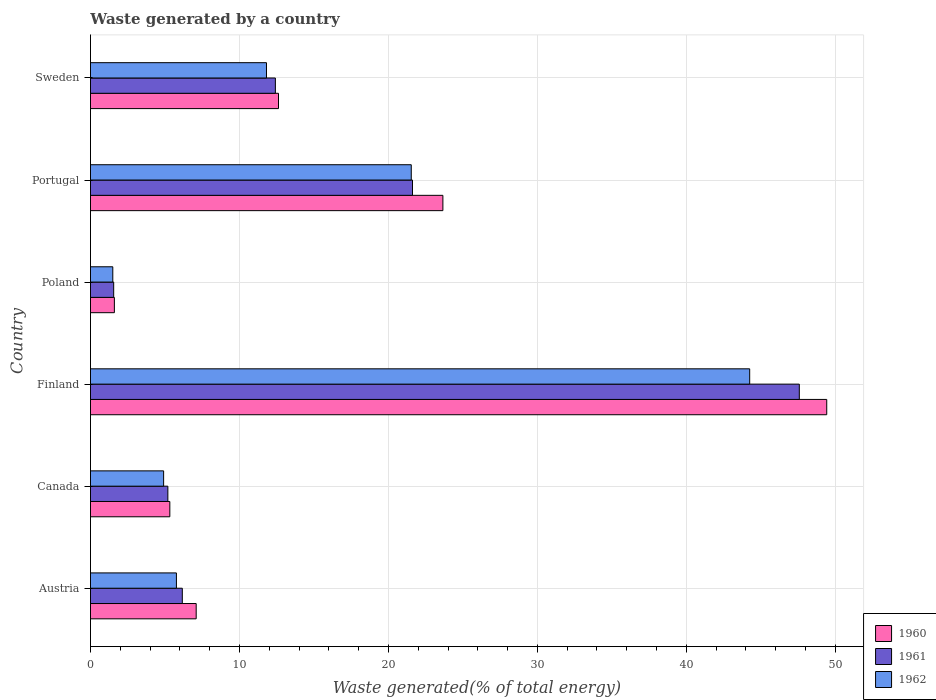How many different coloured bars are there?
Provide a short and direct response. 3. Are the number of bars on each tick of the Y-axis equal?
Ensure brevity in your answer.  Yes. What is the label of the 1st group of bars from the top?
Your answer should be very brief. Sweden. In how many cases, is the number of bars for a given country not equal to the number of legend labels?
Your answer should be very brief. 0. What is the total waste generated in 1960 in Poland?
Your response must be concise. 1.6. Across all countries, what is the maximum total waste generated in 1960?
Provide a succinct answer. 49.42. Across all countries, what is the minimum total waste generated in 1962?
Your answer should be compact. 1.5. In which country was the total waste generated in 1960 minimum?
Keep it short and to the point. Poland. What is the total total waste generated in 1961 in the graph?
Your response must be concise. 94.53. What is the difference between the total waste generated in 1962 in Austria and that in Portugal?
Your response must be concise. -15.76. What is the difference between the total waste generated in 1960 in Portugal and the total waste generated in 1961 in Sweden?
Your answer should be compact. 11.24. What is the average total waste generated in 1962 per country?
Ensure brevity in your answer.  14.96. What is the difference between the total waste generated in 1962 and total waste generated in 1961 in Finland?
Provide a short and direct response. -3.33. In how many countries, is the total waste generated in 1960 greater than 24 %?
Ensure brevity in your answer.  1. What is the ratio of the total waste generated in 1962 in Austria to that in Canada?
Provide a short and direct response. 1.17. Is the total waste generated in 1962 in Poland less than that in Sweden?
Your answer should be compact. Yes. Is the difference between the total waste generated in 1962 in Canada and Sweden greater than the difference between the total waste generated in 1961 in Canada and Sweden?
Your response must be concise. Yes. What is the difference between the highest and the second highest total waste generated in 1961?
Keep it short and to the point. 25.96. What is the difference between the highest and the lowest total waste generated in 1962?
Provide a succinct answer. 42.75. Is the sum of the total waste generated in 1962 in Portugal and Sweden greater than the maximum total waste generated in 1961 across all countries?
Offer a very short reply. No. What does the 3rd bar from the bottom in Poland represents?
Your response must be concise. 1962. How many bars are there?
Your answer should be compact. 18. Are all the bars in the graph horizontal?
Offer a terse response. Yes. Does the graph contain any zero values?
Provide a short and direct response. No. Where does the legend appear in the graph?
Make the answer very short. Bottom right. How are the legend labels stacked?
Your answer should be compact. Vertical. What is the title of the graph?
Your answer should be compact. Waste generated by a country. Does "2007" appear as one of the legend labels in the graph?
Keep it short and to the point. No. What is the label or title of the X-axis?
Offer a terse response. Waste generated(% of total energy). What is the label or title of the Y-axis?
Keep it short and to the point. Country. What is the Waste generated(% of total energy) in 1960 in Austria?
Provide a short and direct response. 7.1. What is the Waste generated(% of total energy) of 1961 in Austria?
Ensure brevity in your answer.  6.16. What is the Waste generated(% of total energy) of 1962 in Austria?
Make the answer very short. 5.77. What is the Waste generated(% of total energy) of 1960 in Canada?
Give a very brief answer. 5.33. What is the Waste generated(% of total energy) in 1961 in Canada?
Provide a short and direct response. 5.19. What is the Waste generated(% of total energy) of 1962 in Canada?
Your answer should be compact. 4.91. What is the Waste generated(% of total energy) in 1960 in Finland?
Ensure brevity in your answer.  49.42. What is the Waste generated(% of total energy) in 1961 in Finland?
Keep it short and to the point. 47.58. What is the Waste generated(% of total energy) of 1962 in Finland?
Offer a very short reply. 44.25. What is the Waste generated(% of total energy) of 1960 in Poland?
Offer a very short reply. 1.6. What is the Waste generated(% of total energy) of 1961 in Poland?
Your answer should be very brief. 1.56. What is the Waste generated(% of total energy) in 1962 in Poland?
Your response must be concise. 1.5. What is the Waste generated(% of total energy) in 1960 in Portugal?
Ensure brevity in your answer.  23.66. What is the Waste generated(% of total energy) in 1961 in Portugal?
Your answer should be compact. 21.62. What is the Waste generated(% of total energy) in 1962 in Portugal?
Your answer should be very brief. 21.53. What is the Waste generated(% of total energy) in 1960 in Sweden?
Make the answer very short. 12.62. What is the Waste generated(% of total energy) of 1961 in Sweden?
Your answer should be compact. 12.41. What is the Waste generated(% of total energy) of 1962 in Sweden?
Provide a short and direct response. 11.82. Across all countries, what is the maximum Waste generated(% of total energy) of 1960?
Your answer should be compact. 49.42. Across all countries, what is the maximum Waste generated(% of total energy) of 1961?
Keep it short and to the point. 47.58. Across all countries, what is the maximum Waste generated(% of total energy) of 1962?
Give a very brief answer. 44.25. Across all countries, what is the minimum Waste generated(% of total energy) in 1960?
Ensure brevity in your answer.  1.6. Across all countries, what is the minimum Waste generated(% of total energy) in 1961?
Make the answer very short. 1.56. Across all countries, what is the minimum Waste generated(% of total energy) of 1962?
Provide a succinct answer. 1.5. What is the total Waste generated(% of total energy) of 1960 in the graph?
Your response must be concise. 99.73. What is the total Waste generated(% of total energy) of 1961 in the graph?
Offer a very short reply. 94.53. What is the total Waste generated(% of total energy) of 1962 in the graph?
Make the answer very short. 89.78. What is the difference between the Waste generated(% of total energy) of 1960 in Austria and that in Canada?
Give a very brief answer. 1.77. What is the difference between the Waste generated(% of total energy) in 1961 in Austria and that in Canada?
Your answer should be compact. 0.97. What is the difference between the Waste generated(% of total energy) of 1962 in Austria and that in Canada?
Your response must be concise. 0.86. What is the difference between the Waste generated(% of total energy) in 1960 in Austria and that in Finland?
Ensure brevity in your answer.  -42.33. What is the difference between the Waste generated(% of total energy) of 1961 in Austria and that in Finland?
Your answer should be very brief. -41.42. What is the difference between the Waste generated(% of total energy) of 1962 in Austria and that in Finland?
Ensure brevity in your answer.  -38.48. What is the difference between the Waste generated(% of total energy) of 1960 in Austria and that in Poland?
Offer a very short reply. 5.49. What is the difference between the Waste generated(% of total energy) in 1961 in Austria and that in Poland?
Offer a terse response. 4.61. What is the difference between the Waste generated(% of total energy) of 1962 in Austria and that in Poland?
Your answer should be very brief. 4.27. What is the difference between the Waste generated(% of total energy) in 1960 in Austria and that in Portugal?
Keep it short and to the point. -16.56. What is the difference between the Waste generated(% of total energy) of 1961 in Austria and that in Portugal?
Make the answer very short. -15.45. What is the difference between the Waste generated(% of total energy) in 1962 in Austria and that in Portugal?
Your answer should be compact. -15.76. What is the difference between the Waste generated(% of total energy) in 1960 in Austria and that in Sweden?
Provide a succinct answer. -5.52. What is the difference between the Waste generated(% of total energy) of 1961 in Austria and that in Sweden?
Provide a short and direct response. -6.25. What is the difference between the Waste generated(% of total energy) of 1962 in Austria and that in Sweden?
Give a very brief answer. -6.05. What is the difference between the Waste generated(% of total energy) of 1960 in Canada and that in Finland?
Provide a succinct answer. -44.1. What is the difference between the Waste generated(% of total energy) of 1961 in Canada and that in Finland?
Ensure brevity in your answer.  -42.39. What is the difference between the Waste generated(% of total energy) of 1962 in Canada and that in Finland?
Your answer should be compact. -39.34. What is the difference between the Waste generated(% of total energy) in 1960 in Canada and that in Poland?
Offer a very short reply. 3.72. What is the difference between the Waste generated(% of total energy) of 1961 in Canada and that in Poland?
Your answer should be compact. 3.64. What is the difference between the Waste generated(% of total energy) in 1962 in Canada and that in Poland?
Your answer should be compact. 3.41. What is the difference between the Waste generated(% of total energy) of 1960 in Canada and that in Portugal?
Ensure brevity in your answer.  -18.33. What is the difference between the Waste generated(% of total energy) in 1961 in Canada and that in Portugal?
Your answer should be compact. -16.42. What is the difference between the Waste generated(% of total energy) in 1962 in Canada and that in Portugal?
Keep it short and to the point. -16.62. What is the difference between the Waste generated(% of total energy) of 1960 in Canada and that in Sweden?
Your answer should be very brief. -7.29. What is the difference between the Waste generated(% of total energy) in 1961 in Canada and that in Sweden?
Your answer should be very brief. -7.22. What is the difference between the Waste generated(% of total energy) of 1962 in Canada and that in Sweden?
Ensure brevity in your answer.  -6.9. What is the difference between the Waste generated(% of total energy) in 1960 in Finland and that in Poland?
Your answer should be very brief. 47.82. What is the difference between the Waste generated(% of total energy) of 1961 in Finland and that in Poland?
Ensure brevity in your answer.  46.02. What is the difference between the Waste generated(% of total energy) of 1962 in Finland and that in Poland?
Give a very brief answer. 42.75. What is the difference between the Waste generated(% of total energy) of 1960 in Finland and that in Portugal?
Give a very brief answer. 25.77. What is the difference between the Waste generated(% of total energy) in 1961 in Finland and that in Portugal?
Ensure brevity in your answer.  25.96. What is the difference between the Waste generated(% of total energy) of 1962 in Finland and that in Portugal?
Your answer should be compact. 22.72. What is the difference between the Waste generated(% of total energy) in 1960 in Finland and that in Sweden?
Your answer should be very brief. 36.8. What is the difference between the Waste generated(% of total energy) of 1961 in Finland and that in Sweden?
Make the answer very short. 35.17. What is the difference between the Waste generated(% of total energy) of 1962 in Finland and that in Sweden?
Your response must be concise. 32.44. What is the difference between the Waste generated(% of total energy) in 1960 in Poland and that in Portugal?
Offer a very short reply. -22.05. What is the difference between the Waste generated(% of total energy) in 1961 in Poland and that in Portugal?
Offer a terse response. -20.06. What is the difference between the Waste generated(% of total energy) of 1962 in Poland and that in Portugal?
Give a very brief answer. -20.03. What is the difference between the Waste generated(% of total energy) in 1960 in Poland and that in Sweden?
Provide a short and direct response. -11.02. What is the difference between the Waste generated(% of total energy) of 1961 in Poland and that in Sweden?
Provide a short and direct response. -10.85. What is the difference between the Waste generated(% of total energy) in 1962 in Poland and that in Sweden?
Provide a short and direct response. -10.32. What is the difference between the Waste generated(% of total energy) of 1960 in Portugal and that in Sweden?
Provide a short and direct response. 11.03. What is the difference between the Waste generated(% of total energy) in 1961 in Portugal and that in Sweden?
Give a very brief answer. 9.2. What is the difference between the Waste generated(% of total energy) in 1962 in Portugal and that in Sweden?
Make the answer very short. 9.72. What is the difference between the Waste generated(% of total energy) in 1960 in Austria and the Waste generated(% of total energy) in 1961 in Canada?
Your response must be concise. 1.9. What is the difference between the Waste generated(% of total energy) of 1960 in Austria and the Waste generated(% of total energy) of 1962 in Canada?
Give a very brief answer. 2.19. What is the difference between the Waste generated(% of total energy) of 1961 in Austria and the Waste generated(% of total energy) of 1962 in Canada?
Give a very brief answer. 1.25. What is the difference between the Waste generated(% of total energy) in 1960 in Austria and the Waste generated(% of total energy) in 1961 in Finland?
Your response must be concise. -40.48. What is the difference between the Waste generated(% of total energy) of 1960 in Austria and the Waste generated(% of total energy) of 1962 in Finland?
Give a very brief answer. -37.15. What is the difference between the Waste generated(% of total energy) of 1961 in Austria and the Waste generated(% of total energy) of 1962 in Finland?
Provide a succinct answer. -38.09. What is the difference between the Waste generated(% of total energy) in 1960 in Austria and the Waste generated(% of total energy) in 1961 in Poland?
Keep it short and to the point. 5.54. What is the difference between the Waste generated(% of total energy) in 1960 in Austria and the Waste generated(% of total energy) in 1962 in Poland?
Keep it short and to the point. 5.6. What is the difference between the Waste generated(% of total energy) in 1961 in Austria and the Waste generated(% of total energy) in 1962 in Poland?
Offer a terse response. 4.67. What is the difference between the Waste generated(% of total energy) of 1960 in Austria and the Waste generated(% of total energy) of 1961 in Portugal?
Offer a terse response. -14.52. What is the difference between the Waste generated(% of total energy) in 1960 in Austria and the Waste generated(% of total energy) in 1962 in Portugal?
Make the answer very short. -14.44. What is the difference between the Waste generated(% of total energy) of 1961 in Austria and the Waste generated(% of total energy) of 1962 in Portugal?
Give a very brief answer. -15.37. What is the difference between the Waste generated(% of total energy) of 1960 in Austria and the Waste generated(% of total energy) of 1961 in Sweden?
Offer a very short reply. -5.32. What is the difference between the Waste generated(% of total energy) in 1960 in Austria and the Waste generated(% of total energy) in 1962 in Sweden?
Provide a short and direct response. -4.72. What is the difference between the Waste generated(% of total energy) of 1961 in Austria and the Waste generated(% of total energy) of 1962 in Sweden?
Your response must be concise. -5.65. What is the difference between the Waste generated(% of total energy) in 1960 in Canada and the Waste generated(% of total energy) in 1961 in Finland?
Your response must be concise. -42.25. What is the difference between the Waste generated(% of total energy) in 1960 in Canada and the Waste generated(% of total energy) in 1962 in Finland?
Your answer should be compact. -38.92. What is the difference between the Waste generated(% of total energy) of 1961 in Canada and the Waste generated(% of total energy) of 1962 in Finland?
Provide a succinct answer. -39.06. What is the difference between the Waste generated(% of total energy) in 1960 in Canada and the Waste generated(% of total energy) in 1961 in Poland?
Provide a short and direct response. 3.77. What is the difference between the Waste generated(% of total energy) in 1960 in Canada and the Waste generated(% of total energy) in 1962 in Poland?
Offer a very short reply. 3.83. What is the difference between the Waste generated(% of total energy) in 1961 in Canada and the Waste generated(% of total energy) in 1962 in Poland?
Offer a terse response. 3.7. What is the difference between the Waste generated(% of total energy) of 1960 in Canada and the Waste generated(% of total energy) of 1961 in Portugal?
Your answer should be very brief. -16.29. What is the difference between the Waste generated(% of total energy) in 1960 in Canada and the Waste generated(% of total energy) in 1962 in Portugal?
Your answer should be very brief. -16.21. What is the difference between the Waste generated(% of total energy) of 1961 in Canada and the Waste generated(% of total energy) of 1962 in Portugal?
Your answer should be compact. -16.34. What is the difference between the Waste generated(% of total energy) in 1960 in Canada and the Waste generated(% of total energy) in 1961 in Sweden?
Provide a short and direct response. -7.08. What is the difference between the Waste generated(% of total energy) in 1960 in Canada and the Waste generated(% of total energy) in 1962 in Sweden?
Ensure brevity in your answer.  -6.49. What is the difference between the Waste generated(% of total energy) in 1961 in Canada and the Waste generated(% of total energy) in 1962 in Sweden?
Your answer should be very brief. -6.62. What is the difference between the Waste generated(% of total energy) of 1960 in Finland and the Waste generated(% of total energy) of 1961 in Poland?
Keep it short and to the point. 47.86. What is the difference between the Waste generated(% of total energy) in 1960 in Finland and the Waste generated(% of total energy) in 1962 in Poland?
Offer a terse response. 47.92. What is the difference between the Waste generated(% of total energy) of 1961 in Finland and the Waste generated(% of total energy) of 1962 in Poland?
Ensure brevity in your answer.  46.08. What is the difference between the Waste generated(% of total energy) of 1960 in Finland and the Waste generated(% of total energy) of 1961 in Portugal?
Make the answer very short. 27.81. What is the difference between the Waste generated(% of total energy) of 1960 in Finland and the Waste generated(% of total energy) of 1962 in Portugal?
Provide a succinct answer. 27.89. What is the difference between the Waste generated(% of total energy) of 1961 in Finland and the Waste generated(% of total energy) of 1962 in Portugal?
Your answer should be compact. 26.05. What is the difference between the Waste generated(% of total energy) in 1960 in Finland and the Waste generated(% of total energy) in 1961 in Sweden?
Your answer should be very brief. 37.01. What is the difference between the Waste generated(% of total energy) of 1960 in Finland and the Waste generated(% of total energy) of 1962 in Sweden?
Ensure brevity in your answer.  37.61. What is the difference between the Waste generated(% of total energy) in 1961 in Finland and the Waste generated(% of total energy) in 1962 in Sweden?
Your response must be concise. 35.77. What is the difference between the Waste generated(% of total energy) in 1960 in Poland and the Waste generated(% of total energy) in 1961 in Portugal?
Offer a terse response. -20.01. What is the difference between the Waste generated(% of total energy) of 1960 in Poland and the Waste generated(% of total energy) of 1962 in Portugal?
Offer a terse response. -19.93. What is the difference between the Waste generated(% of total energy) of 1961 in Poland and the Waste generated(% of total energy) of 1962 in Portugal?
Your answer should be very brief. -19.98. What is the difference between the Waste generated(% of total energy) of 1960 in Poland and the Waste generated(% of total energy) of 1961 in Sweden?
Give a very brief answer. -10.81. What is the difference between the Waste generated(% of total energy) of 1960 in Poland and the Waste generated(% of total energy) of 1962 in Sweden?
Provide a succinct answer. -10.21. What is the difference between the Waste generated(% of total energy) in 1961 in Poland and the Waste generated(% of total energy) in 1962 in Sweden?
Make the answer very short. -10.26. What is the difference between the Waste generated(% of total energy) in 1960 in Portugal and the Waste generated(% of total energy) in 1961 in Sweden?
Your answer should be compact. 11.24. What is the difference between the Waste generated(% of total energy) of 1960 in Portugal and the Waste generated(% of total energy) of 1962 in Sweden?
Provide a short and direct response. 11.84. What is the difference between the Waste generated(% of total energy) of 1961 in Portugal and the Waste generated(% of total energy) of 1962 in Sweden?
Ensure brevity in your answer.  9.8. What is the average Waste generated(% of total energy) in 1960 per country?
Give a very brief answer. 16.62. What is the average Waste generated(% of total energy) of 1961 per country?
Ensure brevity in your answer.  15.75. What is the average Waste generated(% of total energy) in 1962 per country?
Keep it short and to the point. 14.96. What is the difference between the Waste generated(% of total energy) in 1960 and Waste generated(% of total energy) in 1961 in Austria?
Provide a short and direct response. 0.93. What is the difference between the Waste generated(% of total energy) of 1960 and Waste generated(% of total energy) of 1962 in Austria?
Your response must be concise. 1.33. What is the difference between the Waste generated(% of total energy) of 1961 and Waste generated(% of total energy) of 1962 in Austria?
Provide a short and direct response. 0.4. What is the difference between the Waste generated(% of total energy) in 1960 and Waste generated(% of total energy) in 1961 in Canada?
Your answer should be very brief. 0.13. What is the difference between the Waste generated(% of total energy) of 1960 and Waste generated(% of total energy) of 1962 in Canada?
Ensure brevity in your answer.  0.42. What is the difference between the Waste generated(% of total energy) in 1961 and Waste generated(% of total energy) in 1962 in Canada?
Your answer should be compact. 0.28. What is the difference between the Waste generated(% of total energy) in 1960 and Waste generated(% of total energy) in 1961 in Finland?
Your answer should be very brief. 1.84. What is the difference between the Waste generated(% of total energy) of 1960 and Waste generated(% of total energy) of 1962 in Finland?
Ensure brevity in your answer.  5.17. What is the difference between the Waste generated(% of total energy) of 1961 and Waste generated(% of total energy) of 1962 in Finland?
Your answer should be compact. 3.33. What is the difference between the Waste generated(% of total energy) in 1960 and Waste generated(% of total energy) in 1961 in Poland?
Keep it short and to the point. 0.05. What is the difference between the Waste generated(% of total energy) of 1960 and Waste generated(% of total energy) of 1962 in Poland?
Your response must be concise. 0.11. What is the difference between the Waste generated(% of total energy) in 1961 and Waste generated(% of total energy) in 1962 in Poland?
Your answer should be very brief. 0.06. What is the difference between the Waste generated(% of total energy) in 1960 and Waste generated(% of total energy) in 1961 in Portugal?
Your response must be concise. 2.04. What is the difference between the Waste generated(% of total energy) of 1960 and Waste generated(% of total energy) of 1962 in Portugal?
Make the answer very short. 2.12. What is the difference between the Waste generated(% of total energy) of 1961 and Waste generated(% of total energy) of 1962 in Portugal?
Give a very brief answer. 0.08. What is the difference between the Waste generated(% of total energy) of 1960 and Waste generated(% of total energy) of 1961 in Sweden?
Offer a terse response. 0.21. What is the difference between the Waste generated(% of total energy) in 1960 and Waste generated(% of total energy) in 1962 in Sweden?
Your answer should be very brief. 0.81. What is the difference between the Waste generated(% of total energy) in 1961 and Waste generated(% of total energy) in 1962 in Sweden?
Your response must be concise. 0.6. What is the ratio of the Waste generated(% of total energy) of 1960 in Austria to that in Canada?
Keep it short and to the point. 1.33. What is the ratio of the Waste generated(% of total energy) of 1961 in Austria to that in Canada?
Provide a short and direct response. 1.19. What is the ratio of the Waste generated(% of total energy) of 1962 in Austria to that in Canada?
Your response must be concise. 1.17. What is the ratio of the Waste generated(% of total energy) of 1960 in Austria to that in Finland?
Your response must be concise. 0.14. What is the ratio of the Waste generated(% of total energy) in 1961 in Austria to that in Finland?
Ensure brevity in your answer.  0.13. What is the ratio of the Waste generated(% of total energy) of 1962 in Austria to that in Finland?
Offer a terse response. 0.13. What is the ratio of the Waste generated(% of total energy) of 1960 in Austria to that in Poland?
Ensure brevity in your answer.  4.42. What is the ratio of the Waste generated(% of total energy) of 1961 in Austria to that in Poland?
Give a very brief answer. 3.96. What is the ratio of the Waste generated(% of total energy) of 1962 in Austria to that in Poland?
Your answer should be compact. 3.85. What is the ratio of the Waste generated(% of total energy) of 1961 in Austria to that in Portugal?
Offer a terse response. 0.29. What is the ratio of the Waste generated(% of total energy) in 1962 in Austria to that in Portugal?
Your answer should be very brief. 0.27. What is the ratio of the Waste generated(% of total energy) in 1960 in Austria to that in Sweden?
Provide a short and direct response. 0.56. What is the ratio of the Waste generated(% of total energy) of 1961 in Austria to that in Sweden?
Give a very brief answer. 0.5. What is the ratio of the Waste generated(% of total energy) in 1962 in Austria to that in Sweden?
Ensure brevity in your answer.  0.49. What is the ratio of the Waste generated(% of total energy) in 1960 in Canada to that in Finland?
Provide a succinct answer. 0.11. What is the ratio of the Waste generated(% of total energy) in 1961 in Canada to that in Finland?
Ensure brevity in your answer.  0.11. What is the ratio of the Waste generated(% of total energy) in 1962 in Canada to that in Finland?
Your response must be concise. 0.11. What is the ratio of the Waste generated(% of total energy) in 1960 in Canada to that in Poland?
Give a very brief answer. 3.32. What is the ratio of the Waste generated(% of total energy) in 1961 in Canada to that in Poland?
Offer a very short reply. 3.33. What is the ratio of the Waste generated(% of total energy) of 1962 in Canada to that in Poland?
Offer a very short reply. 3.28. What is the ratio of the Waste generated(% of total energy) in 1960 in Canada to that in Portugal?
Ensure brevity in your answer.  0.23. What is the ratio of the Waste generated(% of total energy) of 1961 in Canada to that in Portugal?
Ensure brevity in your answer.  0.24. What is the ratio of the Waste generated(% of total energy) of 1962 in Canada to that in Portugal?
Provide a succinct answer. 0.23. What is the ratio of the Waste generated(% of total energy) in 1960 in Canada to that in Sweden?
Provide a short and direct response. 0.42. What is the ratio of the Waste generated(% of total energy) in 1961 in Canada to that in Sweden?
Make the answer very short. 0.42. What is the ratio of the Waste generated(% of total energy) in 1962 in Canada to that in Sweden?
Give a very brief answer. 0.42. What is the ratio of the Waste generated(% of total energy) in 1960 in Finland to that in Poland?
Your response must be concise. 30.8. What is the ratio of the Waste generated(% of total energy) of 1961 in Finland to that in Poland?
Your answer should be very brief. 30.53. What is the ratio of the Waste generated(% of total energy) of 1962 in Finland to that in Poland?
Your response must be concise. 29.52. What is the ratio of the Waste generated(% of total energy) in 1960 in Finland to that in Portugal?
Keep it short and to the point. 2.09. What is the ratio of the Waste generated(% of total energy) in 1961 in Finland to that in Portugal?
Give a very brief answer. 2.2. What is the ratio of the Waste generated(% of total energy) of 1962 in Finland to that in Portugal?
Your response must be concise. 2.05. What is the ratio of the Waste generated(% of total energy) in 1960 in Finland to that in Sweden?
Offer a very short reply. 3.92. What is the ratio of the Waste generated(% of total energy) of 1961 in Finland to that in Sweden?
Give a very brief answer. 3.83. What is the ratio of the Waste generated(% of total energy) of 1962 in Finland to that in Sweden?
Ensure brevity in your answer.  3.75. What is the ratio of the Waste generated(% of total energy) of 1960 in Poland to that in Portugal?
Your answer should be very brief. 0.07. What is the ratio of the Waste generated(% of total energy) of 1961 in Poland to that in Portugal?
Provide a succinct answer. 0.07. What is the ratio of the Waste generated(% of total energy) of 1962 in Poland to that in Portugal?
Offer a terse response. 0.07. What is the ratio of the Waste generated(% of total energy) in 1960 in Poland to that in Sweden?
Your response must be concise. 0.13. What is the ratio of the Waste generated(% of total energy) of 1961 in Poland to that in Sweden?
Offer a terse response. 0.13. What is the ratio of the Waste generated(% of total energy) in 1962 in Poland to that in Sweden?
Provide a succinct answer. 0.13. What is the ratio of the Waste generated(% of total energy) of 1960 in Portugal to that in Sweden?
Offer a very short reply. 1.87. What is the ratio of the Waste generated(% of total energy) of 1961 in Portugal to that in Sweden?
Provide a short and direct response. 1.74. What is the ratio of the Waste generated(% of total energy) in 1962 in Portugal to that in Sweden?
Your answer should be compact. 1.82. What is the difference between the highest and the second highest Waste generated(% of total energy) of 1960?
Keep it short and to the point. 25.77. What is the difference between the highest and the second highest Waste generated(% of total energy) of 1961?
Your answer should be very brief. 25.96. What is the difference between the highest and the second highest Waste generated(% of total energy) of 1962?
Keep it short and to the point. 22.72. What is the difference between the highest and the lowest Waste generated(% of total energy) in 1960?
Keep it short and to the point. 47.82. What is the difference between the highest and the lowest Waste generated(% of total energy) in 1961?
Provide a succinct answer. 46.02. What is the difference between the highest and the lowest Waste generated(% of total energy) in 1962?
Your answer should be compact. 42.75. 